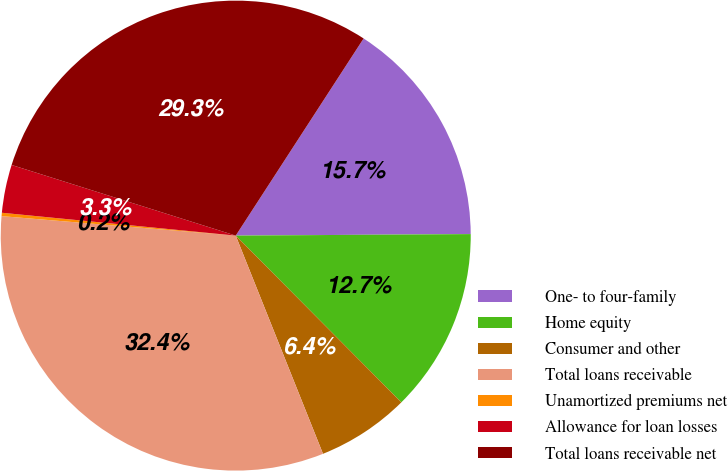Convert chart. <chart><loc_0><loc_0><loc_500><loc_500><pie_chart><fcel>One- to four-family<fcel>Home equity<fcel>Consumer and other<fcel>Total loans receivable<fcel>Unamortized premiums net<fcel>Allowance for loan losses<fcel>Total loans receivable net<nl><fcel>15.74%<fcel>12.66%<fcel>6.39%<fcel>32.38%<fcel>0.23%<fcel>3.31%<fcel>29.3%<nl></chart> 